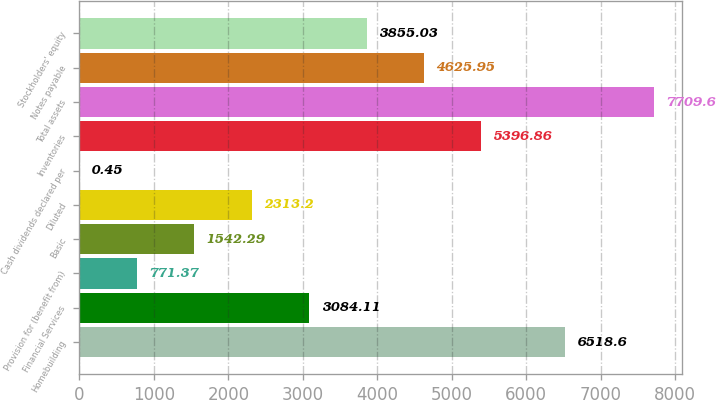Convert chart. <chart><loc_0><loc_0><loc_500><loc_500><bar_chart><fcel>Homebuilding<fcel>Financial Services<fcel>Provision for (benefit from)<fcel>Basic<fcel>Diluted<fcel>Cash dividends declared per<fcel>Inventories<fcel>Total assets<fcel>Notes payable<fcel>Stockholders' equity<nl><fcel>6518.6<fcel>3084.11<fcel>771.37<fcel>1542.29<fcel>2313.2<fcel>0.45<fcel>5396.86<fcel>7709.6<fcel>4625.95<fcel>3855.03<nl></chart> 